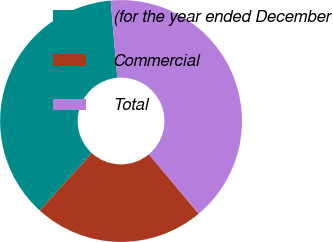Convert chart. <chart><loc_0><loc_0><loc_500><loc_500><pie_chart><fcel>(for the year ended December<fcel>Commercial<fcel>Total<nl><fcel>36.9%<fcel>22.82%<fcel>40.28%<nl></chart> 